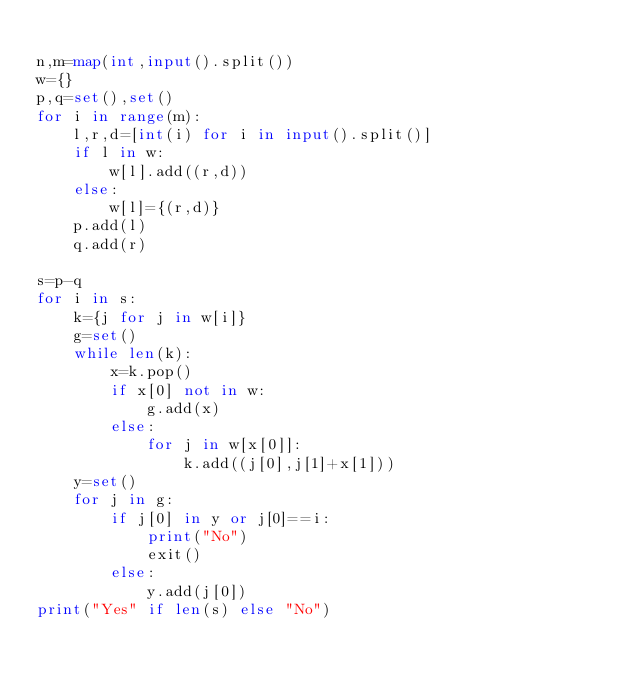Convert code to text. <code><loc_0><loc_0><loc_500><loc_500><_Python_>
n,m=map(int,input().split())
w={}
p,q=set(),set()
for i in range(m):
    l,r,d=[int(i) for i in input().split()]
    if l in w:
        w[l].add((r,d))
    else:
        w[l]={(r,d)}
    p.add(l)
    q.add(r)

s=p-q
for i in s:
    k={j for j in w[i]}
    g=set()
    while len(k):
        x=k.pop()
        if x[0] not in w:
            g.add(x)
        else:
            for j in w[x[0]]:
                k.add((j[0],j[1]+x[1]))
    y=set()
    for j in g:
        if j[0] in y or j[0]==i:
            print("No")
            exit()
        else:
            y.add(j[0])
print("Yes" if len(s) else "No")
</code> 